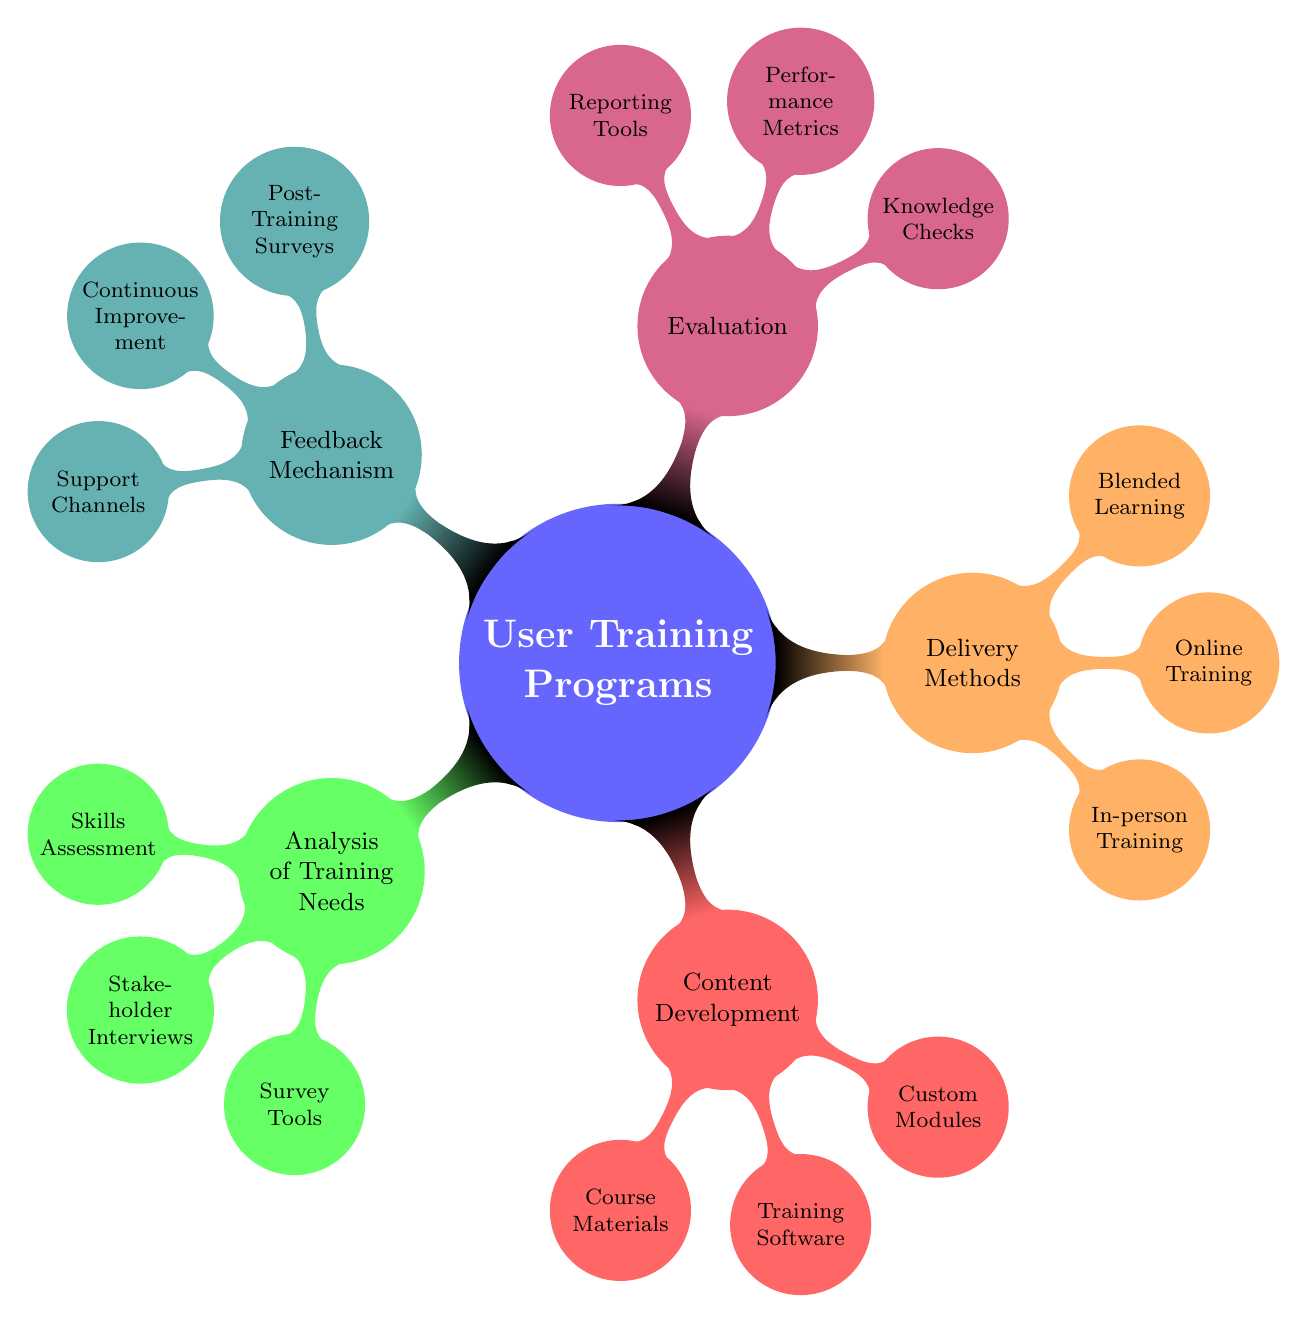What are the main branches of the mind map? The mind map has five main branches identified as Analysis of Training Needs, Content Development, Delivery Methods, Evaluation, and Feedback Mechanism. Each of these branches represents a key component of User Training Programs.
Answer: Analysis of Training Needs, Content Development, Delivery Methods, Evaluation, Feedback Mechanism How many nodes are under "Delivery Methods"? The branch "Delivery Methods" has three child nodes labeled In-person Training, Online Training, and Blended Learning. These are the specific delivery methods listed under this category.
Answer: 3 List one type of tool used in "Survey Tools". Under the "Survey Tools" branch, one example of a tool is "Questionnaires". This specific tool is mentioned as a way to gather feedback and assess training needs.
Answer: Questionnaires Which method includes "Workshops"? "Workshops" are categorized under the "In-person Training" node. This node signifies one of the methods for delivering user training programs.
Answer: In-person Training What does "Continuous Improvement" relate to? "Continuous Improvement" is associated with the "Feedback Mechanism" branch, indicating that this node focuses on enhancing the training process based on feedback collected from participants.
Answer: Feedback Mechanism What are the two components of "Performance Metrics"? The "Performance Metrics" node includes two components: "Completion Rates" and "User Competency Metrics". These metrics are utilized to evaluate the effectiveness of the training programs.
Answer: Completion Rates, User Competency Metrics How many types of Course Materials are mentioned? Under "Course Materials", three types are listed: "User Manuals", "Interactive Tutorials", and "Video Lectures". Thus, there are three distinct types of materials specified.
Answer: 3 What is the relationship between "Knowledge Checks" and "Evaluation"? "Knowledge Checks" are a child node under the "Evaluation" branch, indicating that this type of assessment is a component of how training effectiveness is measured.
Answer: Evaluation Which child node under "Feedback Mechanism" suggests ongoing support? The child node "Support Channels" under the "Feedback Mechanism" branch suggests ongoing support for users after training, providing access to help desks and peer forums.
Answer: Support Channels 